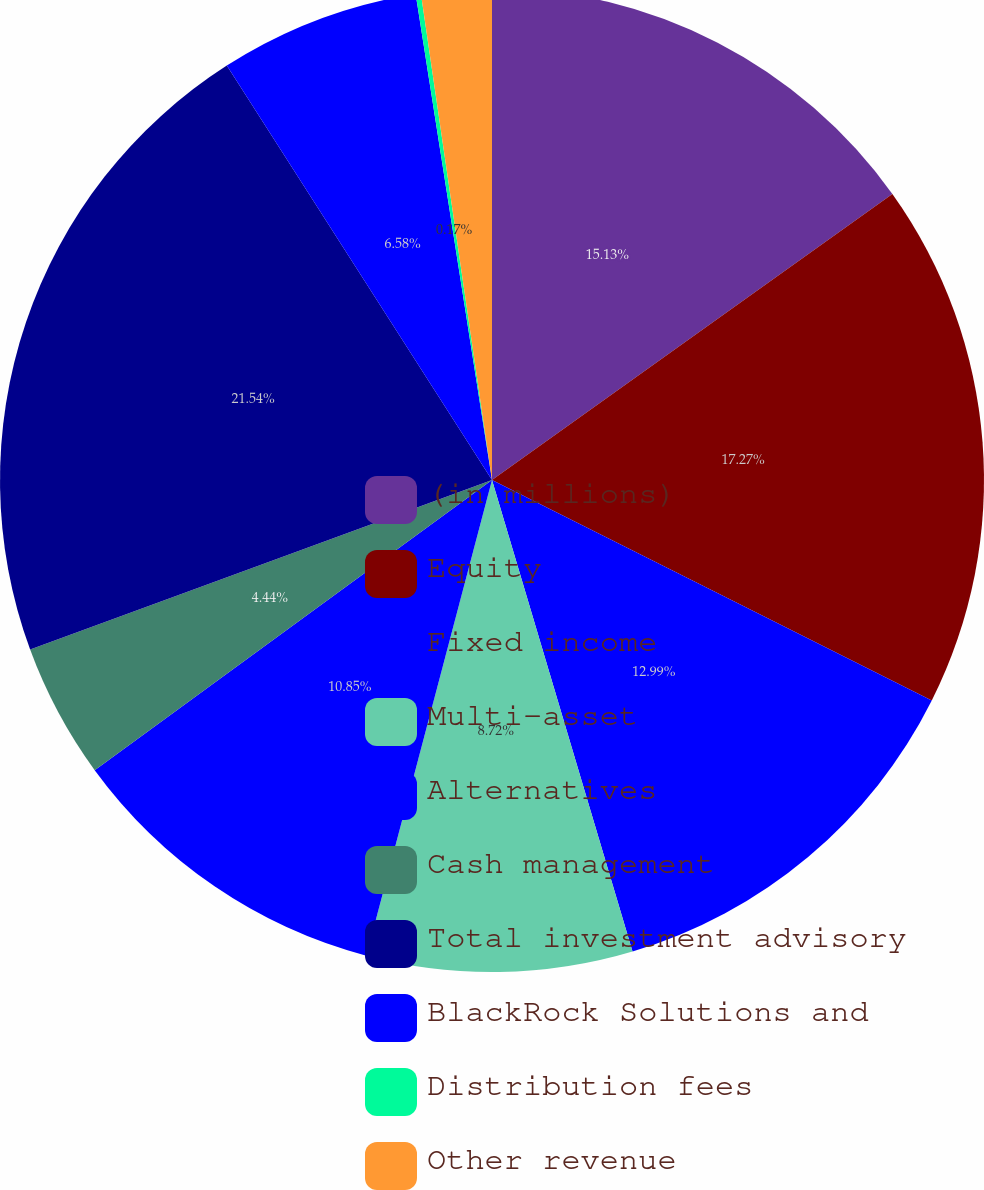Convert chart to OTSL. <chart><loc_0><loc_0><loc_500><loc_500><pie_chart><fcel>(in millions)<fcel>Equity<fcel>Fixed income<fcel>Multi-asset<fcel>Alternatives<fcel>Cash management<fcel>Total investment advisory<fcel>BlackRock Solutions and<fcel>Distribution fees<fcel>Other revenue<nl><fcel>15.13%<fcel>17.27%<fcel>12.99%<fcel>8.72%<fcel>10.85%<fcel>4.44%<fcel>21.54%<fcel>6.58%<fcel>0.17%<fcel>2.31%<nl></chart> 